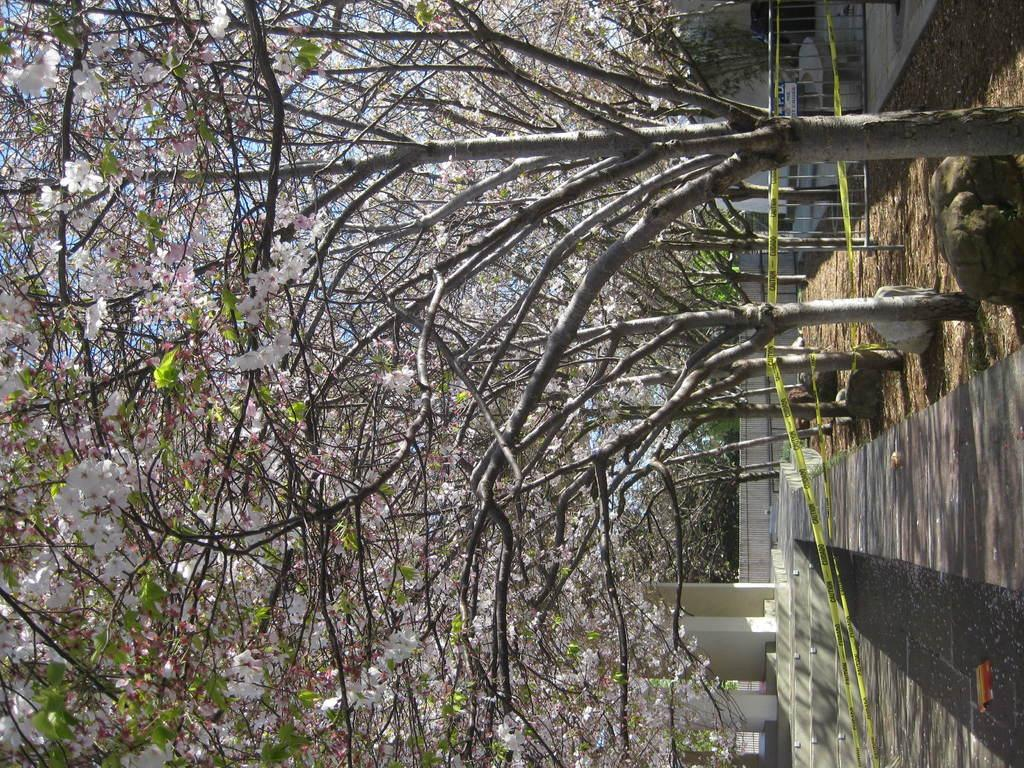What type of vegetation can be seen in the image? There are trees in the image. What architectural feature is present in the image? There are stairs and pillars in the image. What type of structure is visible in the image? There is a building in the image. What is the ground made of in the image? The ground appears to be soil in the image. What type of material is present in the image? There are stones in the image. What signifies a restricted area in the image? Police lines are present in the image. Where is the oven located in the image? There is no oven present in the image. What type of offer is being made by the trees in the image? Trees do not make offers; they are a type of vegetation. 